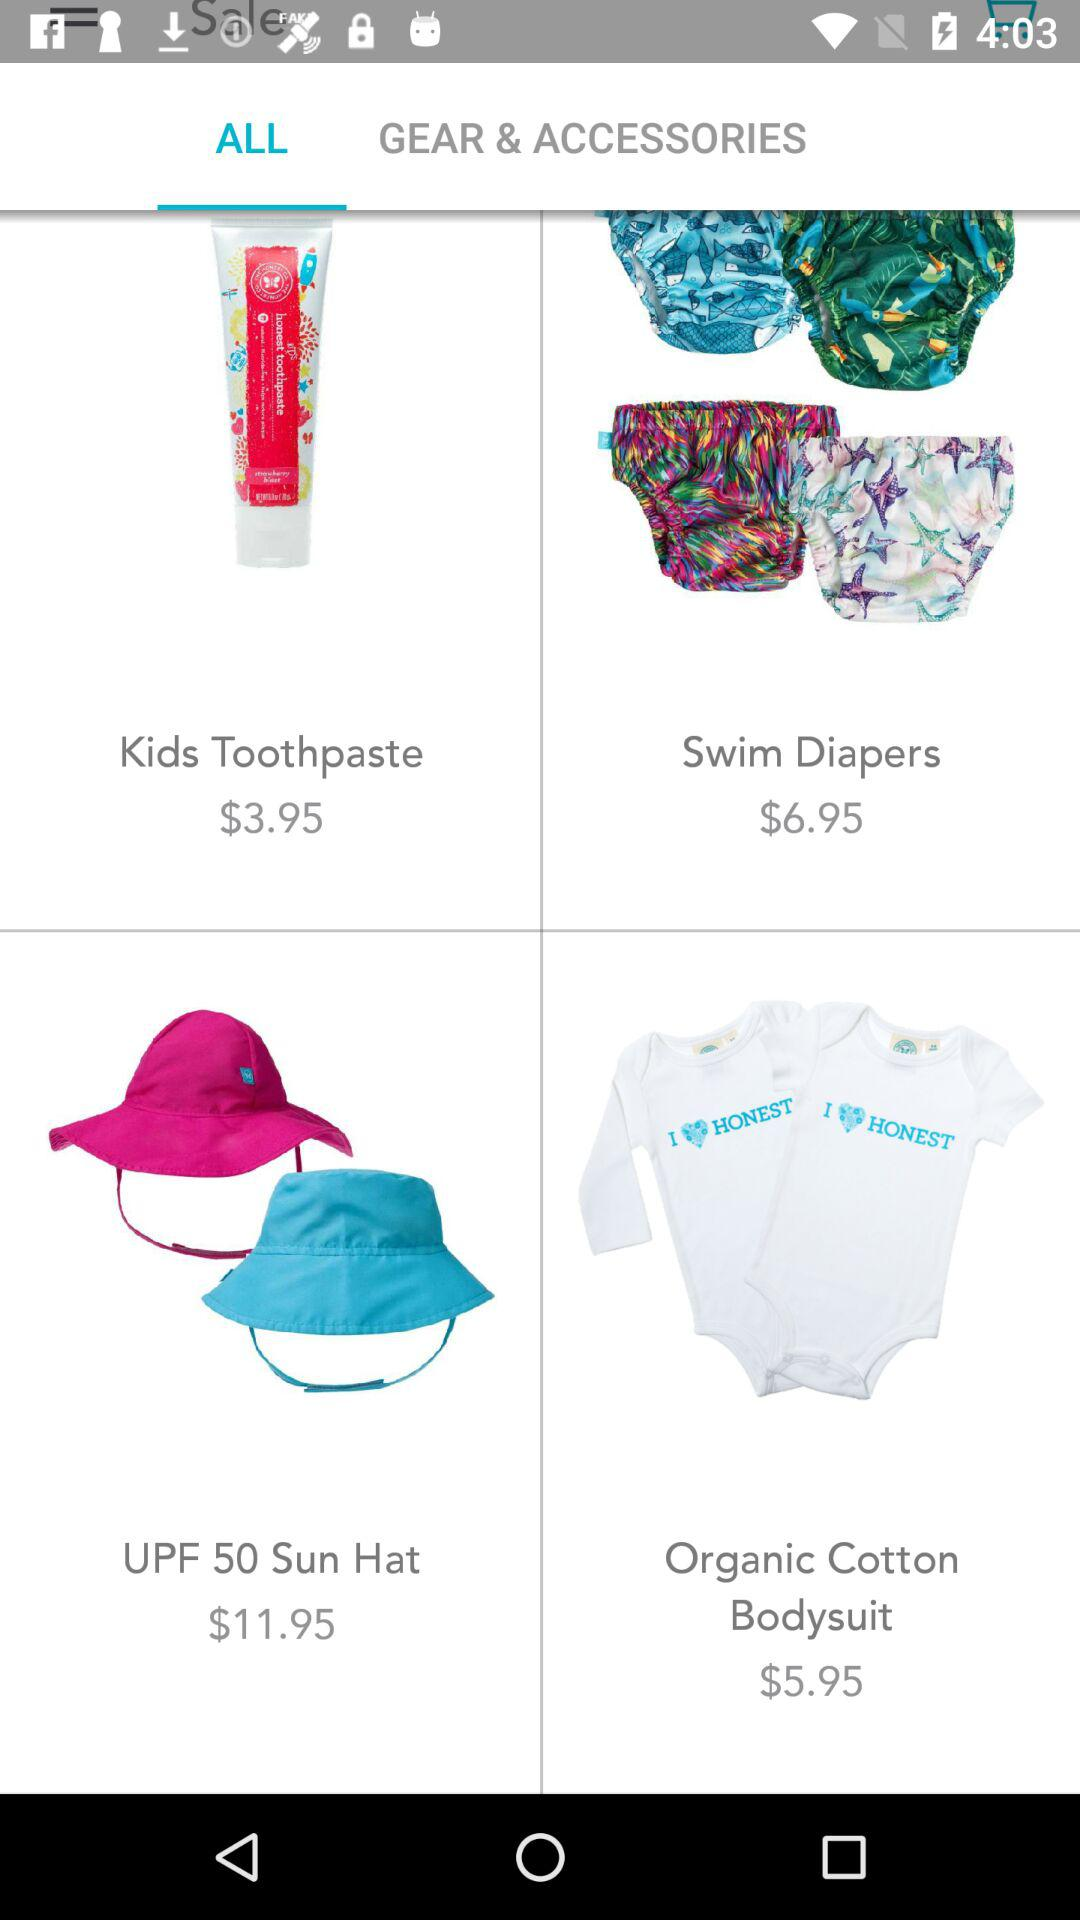What is the price of "UPF 50 Sun Hat"? The price of "UPF 50 Sun Hat" is 11.95 dollars. 